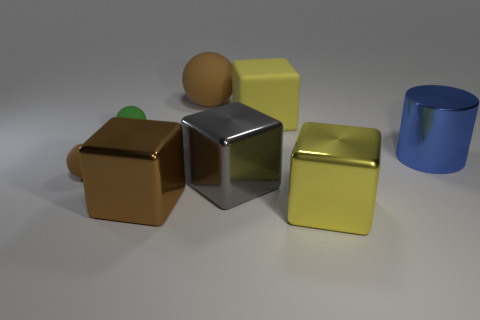Add 1 tiny blue matte spheres. How many objects exist? 9 Subtract all cylinders. How many objects are left? 7 Subtract all big blue metallic things. Subtract all tiny things. How many objects are left? 5 Add 1 green rubber things. How many green rubber things are left? 2 Add 2 brown objects. How many brown objects exist? 5 Subtract 0 yellow cylinders. How many objects are left? 8 